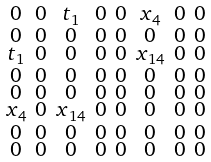Convert formula to latex. <formula><loc_0><loc_0><loc_500><loc_500>\begin{smallmatrix} 0 & 0 & { t _ { 1 } } & 0 & 0 & { x _ { 4 } } & 0 & 0 \\ 0 & 0 & 0 & 0 & 0 & 0 & 0 & 0 \\ { t _ { 1 } } & 0 & 0 & 0 & 0 & { x _ { 1 4 } } & 0 & 0 \\ 0 & 0 & 0 & 0 & 0 & 0 & 0 & 0 \\ 0 & 0 & 0 & 0 & 0 & 0 & 0 & 0 \\ { x _ { 4 } } & 0 & { x _ { 1 4 } } & 0 & 0 & 0 & 0 & 0 \\ 0 & 0 & 0 & 0 & 0 & 0 & 0 & 0 \\ 0 & 0 & 0 & 0 & 0 & 0 & 0 & 0 \end{smallmatrix}</formula> 